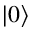<formula> <loc_0><loc_0><loc_500><loc_500>| 0 \rangle</formula> 